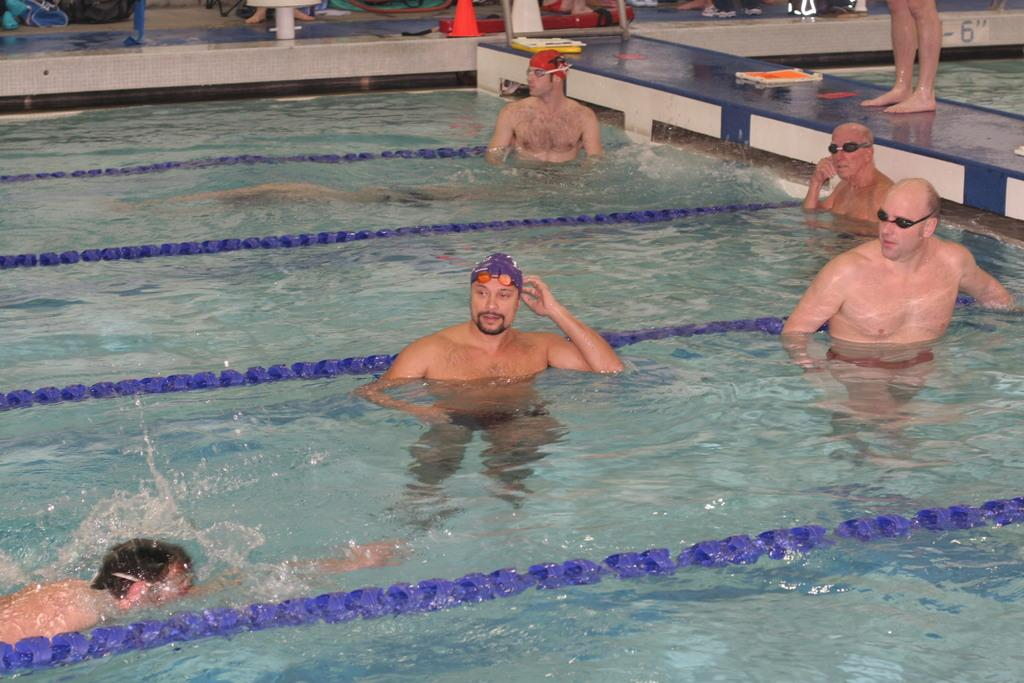What are the people in the image doing? There is a group of persons in the pool. Can you describe the person in the background of the image? There is a person standing in the background on the right side of the image. What type of cable is being used by the person in the image? There is no cable visible in the image. What is the profit made by the person in the image? There is no mention of profit or financial gain in the image. 